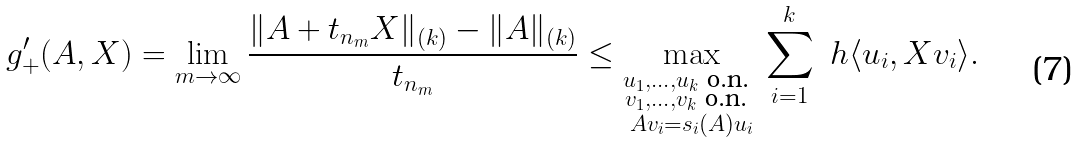Convert formula to latex. <formula><loc_0><loc_0><loc_500><loc_500>g ^ { \prime } _ { + } ( A , X ) = \lim _ { m \rightarrow \infty } \frac { \| A + t _ { n _ { m } } X \| _ { ( k ) } - \| A \| _ { ( k ) } } { t _ { n _ { m } } } \leq \max _ { \substack { \\ u _ { 1 } , \dots , u _ { k } \text { o.n. } \\ v _ { 1 } , \dots , v _ { k } \text { o.n. } \\ A v _ { i } = s _ { i } ( A ) u _ { i } } } \sum _ { i = 1 } ^ { k } \ h \langle u _ { i } , X v _ { i } \rangle .</formula> 